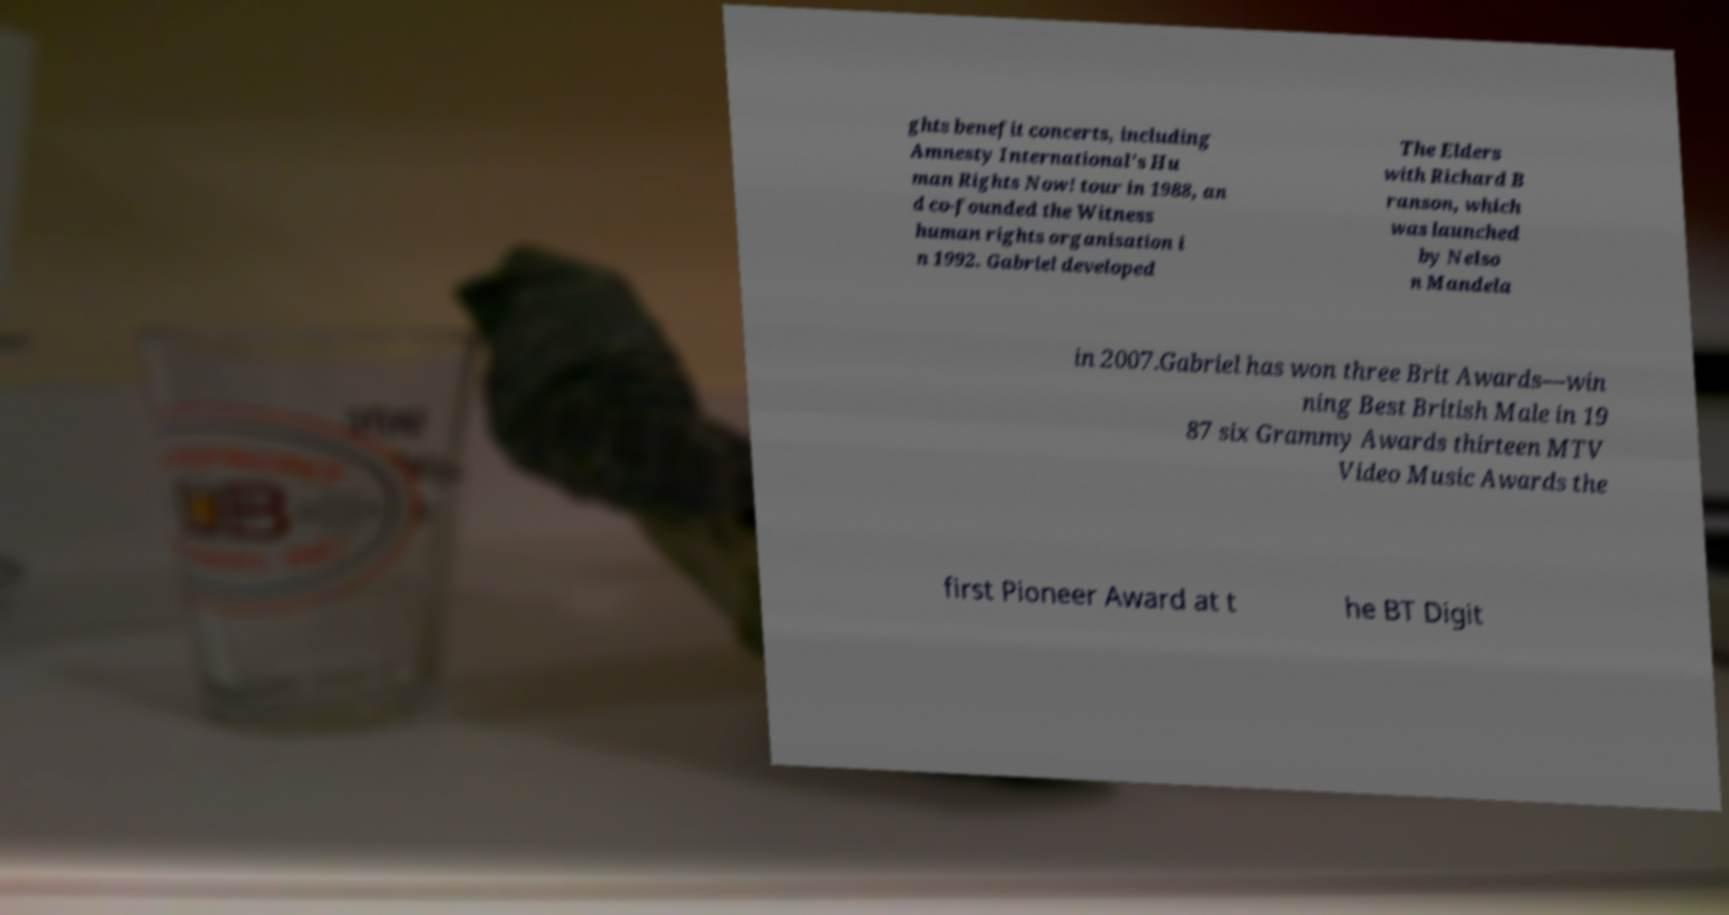Please identify and transcribe the text found in this image. ghts benefit concerts, including Amnesty International's Hu man Rights Now! tour in 1988, an d co-founded the Witness human rights organisation i n 1992. Gabriel developed The Elders with Richard B ranson, which was launched by Nelso n Mandela in 2007.Gabriel has won three Brit Awards—win ning Best British Male in 19 87 six Grammy Awards thirteen MTV Video Music Awards the first Pioneer Award at t he BT Digit 